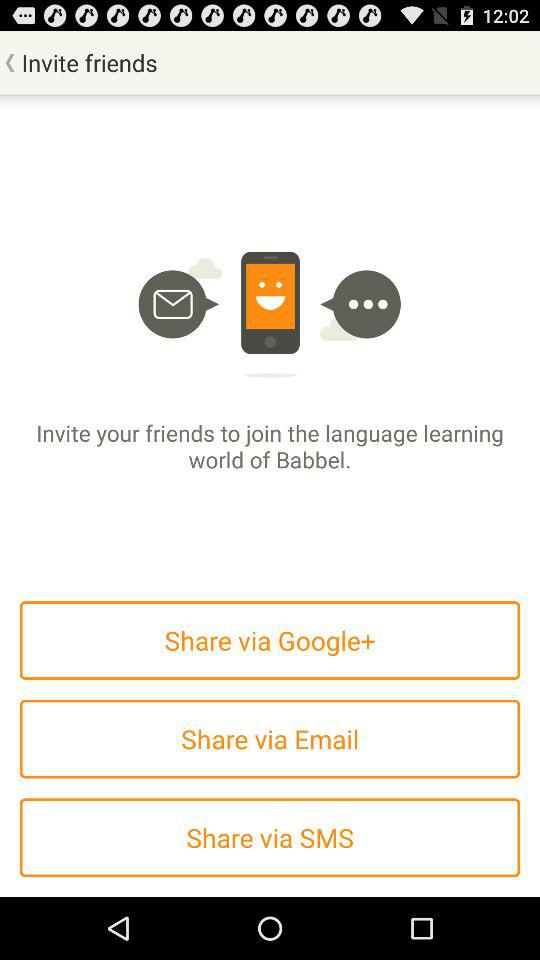How many social media platforms can I use to share my invite?
Answer the question using a single word or phrase. 3 